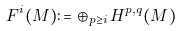<formula> <loc_0><loc_0><loc_500><loc_500>F ^ { i } ( M ) \colon = \oplus _ { p \geq i } \, H ^ { p , q } ( M )</formula> 